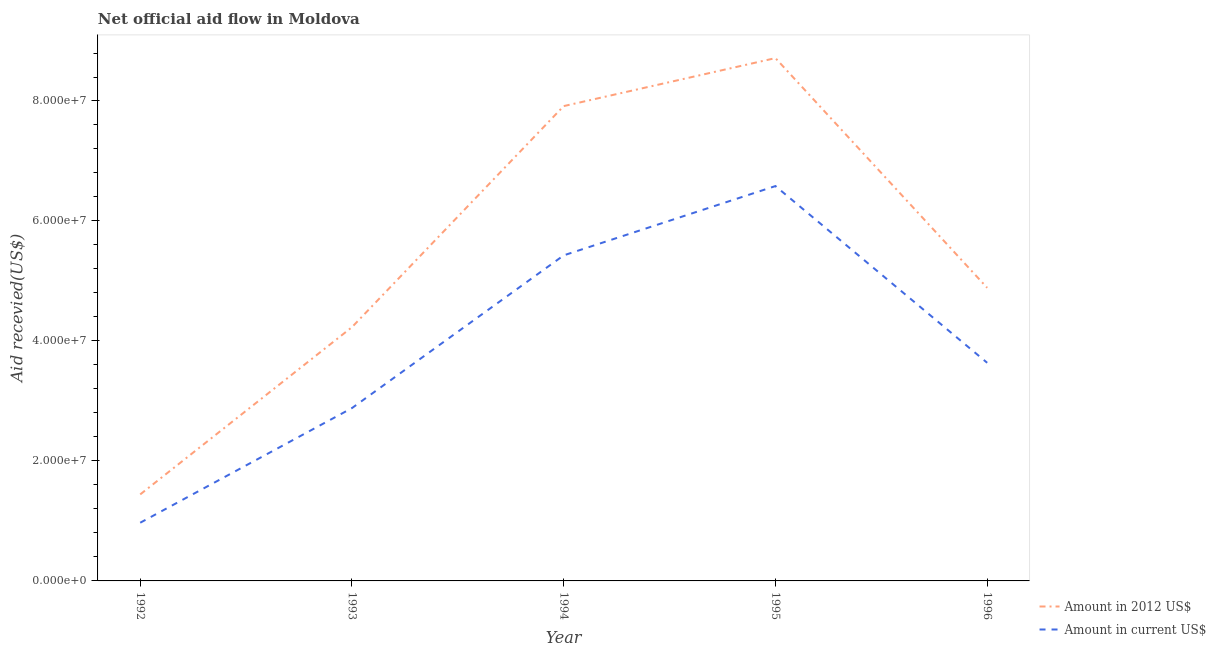Is the number of lines equal to the number of legend labels?
Give a very brief answer. Yes. What is the amount of aid received(expressed in us$) in 1996?
Provide a short and direct response. 3.64e+07. Across all years, what is the maximum amount of aid received(expressed in 2012 us$)?
Your answer should be compact. 8.72e+07. Across all years, what is the minimum amount of aid received(expressed in us$)?
Ensure brevity in your answer.  9.70e+06. In which year was the amount of aid received(expressed in 2012 us$) maximum?
Give a very brief answer. 1995. What is the total amount of aid received(expressed in us$) in the graph?
Give a very brief answer. 1.95e+08. What is the difference between the amount of aid received(expressed in 2012 us$) in 1993 and that in 1995?
Your answer should be very brief. -4.48e+07. What is the difference between the amount of aid received(expressed in us$) in 1994 and the amount of aid received(expressed in 2012 us$) in 1996?
Provide a short and direct response. 5.41e+06. What is the average amount of aid received(expressed in us$) per year?
Offer a very short reply. 3.90e+07. In the year 1996, what is the difference between the amount of aid received(expressed in us$) and amount of aid received(expressed in 2012 us$)?
Ensure brevity in your answer.  -1.25e+07. In how many years, is the amount of aid received(expressed in 2012 us$) greater than 68000000 US$?
Ensure brevity in your answer.  2. What is the ratio of the amount of aid received(expressed in us$) in 1992 to that in 1995?
Offer a very short reply. 0.15. Is the difference between the amount of aid received(expressed in us$) in 1994 and 1996 greater than the difference between the amount of aid received(expressed in 2012 us$) in 1994 and 1996?
Your response must be concise. No. What is the difference between the highest and the second highest amount of aid received(expressed in us$)?
Your response must be concise. 1.16e+07. What is the difference between the highest and the lowest amount of aid received(expressed in 2012 us$)?
Ensure brevity in your answer.  7.27e+07. In how many years, is the amount of aid received(expressed in 2012 us$) greater than the average amount of aid received(expressed in 2012 us$) taken over all years?
Provide a succinct answer. 2. Is the sum of the amount of aid received(expressed in 2012 us$) in 1992 and 1995 greater than the maximum amount of aid received(expressed in us$) across all years?
Provide a short and direct response. Yes. Is the amount of aid received(expressed in us$) strictly less than the amount of aid received(expressed in 2012 us$) over the years?
Your response must be concise. Yes. How many years are there in the graph?
Give a very brief answer. 5. Are the values on the major ticks of Y-axis written in scientific E-notation?
Make the answer very short. Yes. Does the graph contain any zero values?
Your answer should be very brief. No. How are the legend labels stacked?
Keep it short and to the point. Vertical. What is the title of the graph?
Provide a succinct answer. Net official aid flow in Moldova. Does "Secondary education" appear as one of the legend labels in the graph?
Your answer should be compact. No. What is the label or title of the Y-axis?
Make the answer very short. Aid recevied(US$). What is the Aid recevied(US$) in Amount in 2012 US$ in 1992?
Give a very brief answer. 1.44e+07. What is the Aid recevied(US$) of Amount in current US$ in 1992?
Provide a short and direct response. 9.70e+06. What is the Aid recevied(US$) in Amount in 2012 US$ in 1993?
Offer a very short reply. 4.23e+07. What is the Aid recevied(US$) in Amount in current US$ in 1993?
Your answer should be compact. 2.88e+07. What is the Aid recevied(US$) in Amount in 2012 US$ in 1994?
Your response must be concise. 7.92e+07. What is the Aid recevied(US$) in Amount in current US$ in 1994?
Ensure brevity in your answer.  5.43e+07. What is the Aid recevied(US$) in Amount in 2012 US$ in 1995?
Give a very brief answer. 8.72e+07. What is the Aid recevied(US$) in Amount in current US$ in 1995?
Give a very brief answer. 6.58e+07. What is the Aid recevied(US$) of Amount in 2012 US$ in 1996?
Keep it short and to the point. 4.89e+07. What is the Aid recevied(US$) of Amount in current US$ in 1996?
Provide a short and direct response. 3.64e+07. Across all years, what is the maximum Aid recevied(US$) of Amount in 2012 US$?
Provide a short and direct response. 8.72e+07. Across all years, what is the maximum Aid recevied(US$) in Amount in current US$?
Provide a short and direct response. 6.58e+07. Across all years, what is the minimum Aid recevied(US$) of Amount in 2012 US$?
Make the answer very short. 1.44e+07. Across all years, what is the minimum Aid recevied(US$) of Amount in current US$?
Offer a terse response. 9.70e+06. What is the total Aid recevied(US$) of Amount in 2012 US$ in the graph?
Offer a terse response. 2.72e+08. What is the total Aid recevied(US$) of Amount in current US$ in the graph?
Offer a terse response. 1.95e+08. What is the difference between the Aid recevied(US$) in Amount in 2012 US$ in 1992 and that in 1993?
Offer a very short reply. -2.79e+07. What is the difference between the Aid recevied(US$) of Amount in current US$ in 1992 and that in 1993?
Your response must be concise. -1.91e+07. What is the difference between the Aid recevied(US$) of Amount in 2012 US$ in 1992 and that in 1994?
Your answer should be compact. -6.47e+07. What is the difference between the Aid recevied(US$) in Amount in current US$ in 1992 and that in 1994?
Provide a short and direct response. -4.46e+07. What is the difference between the Aid recevied(US$) of Amount in 2012 US$ in 1992 and that in 1995?
Offer a terse response. -7.27e+07. What is the difference between the Aid recevied(US$) in Amount in current US$ in 1992 and that in 1995?
Provide a succinct answer. -5.61e+07. What is the difference between the Aid recevied(US$) of Amount in 2012 US$ in 1992 and that in 1996?
Give a very brief answer. -3.44e+07. What is the difference between the Aid recevied(US$) in Amount in current US$ in 1992 and that in 1996?
Offer a very short reply. -2.67e+07. What is the difference between the Aid recevied(US$) in Amount in 2012 US$ in 1993 and that in 1994?
Provide a short and direct response. -3.68e+07. What is the difference between the Aid recevied(US$) of Amount in current US$ in 1993 and that in 1994?
Offer a terse response. -2.55e+07. What is the difference between the Aid recevied(US$) in Amount in 2012 US$ in 1993 and that in 1995?
Give a very brief answer. -4.48e+07. What is the difference between the Aid recevied(US$) in Amount in current US$ in 1993 and that in 1995?
Offer a very short reply. -3.70e+07. What is the difference between the Aid recevied(US$) in Amount in 2012 US$ in 1993 and that in 1996?
Give a very brief answer. -6.56e+06. What is the difference between the Aid recevied(US$) of Amount in current US$ in 1993 and that in 1996?
Provide a succinct answer. -7.55e+06. What is the difference between the Aid recevied(US$) of Amount in 2012 US$ in 1994 and that in 1995?
Keep it short and to the point. -8.00e+06. What is the difference between the Aid recevied(US$) of Amount in current US$ in 1994 and that in 1995?
Your response must be concise. -1.16e+07. What is the difference between the Aid recevied(US$) in Amount in 2012 US$ in 1994 and that in 1996?
Offer a terse response. 3.03e+07. What is the difference between the Aid recevied(US$) in Amount in current US$ in 1994 and that in 1996?
Your answer should be very brief. 1.79e+07. What is the difference between the Aid recevied(US$) of Amount in 2012 US$ in 1995 and that in 1996?
Keep it short and to the point. 3.83e+07. What is the difference between the Aid recevied(US$) in Amount in current US$ in 1995 and that in 1996?
Your answer should be compact. 2.95e+07. What is the difference between the Aid recevied(US$) of Amount in 2012 US$ in 1992 and the Aid recevied(US$) of Amount in current US$ in 1993?
Your response must be concise. -1.44e+07. What is the difference between the Aid recevied(US$) of Amount in 2012 US$ in 1992 and the Aid recevied(US$) of Amount in current US$ in 1994?
Your answer should be compact. -3.98e+07. What is the difference between the Aid recevied(US$) in Amount in 2012 US$ in 1992 and the Aid recevied(US$) in Amount in current US$ in 1995?
Offer a very short reply. -5.14e+07. What is the difference between the Aid recevied(US$) in Amount in 2012 US$ in 1992 and the Aid recevied(US$) in Amount in current US$ in 1996?
Give a very brief answer. -2.19e+07. What is the difference between the Aid recevied(US$) in Amount in 2012 US$ in 1993 and the Aid recevied(US$) in Amount in current US$ in 1994?
Your response must be concise. -1.20e+07. What is the difference between the Aid recevied(US$) of Amount in 2012 US$ in 1993 and the Aid recevied(US$) of Amount in current US$ in 1995?
Give a very brief answer. -2.35e+07. What is the difference between the Aid recevied(US$) of Amount in 2012 US$ in 1993 and the Aid recevied(US$) of Amount in current US$ in 1996?
Your answer should be very brief. 5.94e+06. What is the difference between the Aid recevied(US$) in Amount in 2012 US$ in 1994 and the Aid recevied(US$) in Amount in current US$ in 1995?
Provide a short and direct response. 1.33e+07. What is the difference between the Aid recevied(US$) in Amount in 2012 US$ in 1994 and the Aid recevied(US$) in Amount in current US$ in 1996?
Make the answer very short. 4.28e+07. What is the difference between the Aid recevied(US$) in Amount in 2012 US$ in 1995 and the Aid recevied(US$) in Amount in current US$ in 1996?
Your response must be concise. 5.08e+07. What is the average Aid recevied(US$) in Amount in 2012 US$ per year?
Make the answer very short. 5.44e+07. What is the average Aid recevied(US$) in Amount in current US$ per year?
Provide a succinct answer. 3.90e+07. In the year 1992, what is the difference between the Aid recevied(US$) of Amount in 2012 US$ and Aid recevied(US$) of Amount in current US$?
Make the answer very short. 4.72e+06. In the year 1993, what is the difference between the Aid recevied(US$) of Amount in 2012 US$ and Aid recevied(US$) of Amount in current US$?
Provide a succinct answer. 1.35e+07. In the year 1994, what is the difference between the Aid recevied(US$) in Amount in 2012 US$ and Aid recevied(US$) in Amount in current US$?
Ensure brevity in your answer.  2.49e+07. In the year 1995, what is the difference between the Aid recevied(US$) of Amount in 2012 US$ and Aid recevied(US$) of Amount in current US$?
Your response must be concise. 2.13e+07. In the year 1996, what is the difference between the Aid recevied(US$) of Amount in 2012 US$ and Aid recevied(US$) of Amount in current US$?
Ensure brevity in your answer.  1.25e+07. What is the ratio of the Aid recevied(US$) in Amount in 2012 US$ in 1992 to that in 1993?
Keep it short and to the point. 0.34. What is the ratio of the Aid recevied(US$) of Amount in current US$ in 1992 to that in 1993?
Provide a succinct answer. 0.34. What is the ratio of the Aid recevied(US$) of Amount in 2012 US$ in 1992 to that in 1994?
Your response must be concise. 0.18. What is the ratio of the Aid recevied(US$) of Amount in current US$ in 1992 to that in 1994?
Offer a very short reply. 0.18. What is the ratio of the Aid recevied(US$) in Amount in 2012 US$ in 1992 to that in 1995?
Your answer should be very brief. 0.17. What is the ratio of the Aid recevied(US$) in Amount in current US$ in 1992 to that in 1995?
Offer a very short reply. 0.15. What is the ratio of the Aid recevied(US$) of Amount in 2012 US$ in 1992 to that in 1996?
Offer a terse response. 0.3. What is the ratio of the Aid recevied(US$) in Amount in current US$ in 1992 to that in 1996?
Give a very brief answer. 0.27. What is the ratio of the Aid recevied(US$) in Amount in 2012 US$ in 1993 to that in 1994?
Give a very brief answer. 0.53. What is the ratio of the Aid recevied(US$) of Amount in current US$ in 1993 to that in 1994?
Your answer should be compact. 0.53. What is the ratio of the Aid recevied(US$) in Amount in 2012 US$ in 1993 to that in 1995?
Ensure brevity in your answer.  0.49. What is the ratio of the Aid recevied(US$) of Amount in current US$ in 1993 to that in 1995?
Your response must be concise. 0.44. What is the ratio of the Aid recevied(US$) of Amount in 2012 US$ in 1993 to that in 1996?
Ensure brevity in your answer.  0.87. What is the ratio of the Aid recevied(US$) of Amount in current US$ in 1993 to that in 1996?
Offer a very short reply. 0.79. What is the ratio of the Aid recevied(US$) in Amount in 2012 US$ in 1994 to that in 1995?
Offer a terse response. 0.91. What is the ratio of the Aid recevied(US$) of Amount in current US$ in 1994 to that in 1995?
Your response must be concise. 0.82. What is the ratio of the Aid recevied(US$) in Amount in 2012 US$ in 1994 to that in 1996?
Keep it short and to the point. 1.62. What is the ratio of the Aid recevied(US$) of Amount in current US$ in 1994 to that in 1996?
Your answer should be compact. 1.49. What is the ratio of the Aid recevied(US$) in Amount in 2012 US$ in 1995 to that in 1996?
Offer a very short reply. 1.78. What is the ratio of the Aid recevied(US$) of Amount in current US$ in 1995 to that in 1996?
Provide a short and direct response. 1.81. What is the difference between the highest and the second highest Aid recevied(US$) of Amount in current US$?
Make the answer very short. 1.16e+07. What is the difference between the highest and the lowest Aid recevied(US$) in Amount in 2012 US$?
Ensure brevity in your answer.  7.27e+07. What is the difference between the highest and the lowest Aid recevied(US$) in Amount in current US$?
Your answer should be compact. 5.61e+07. 